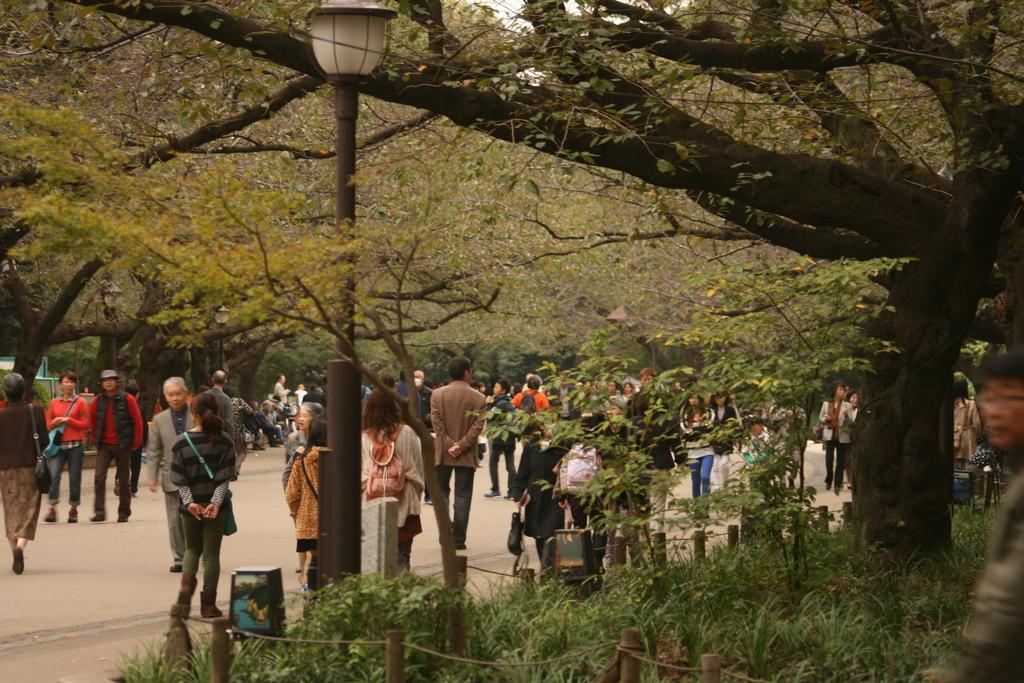What is located at the front of the image? There is a fence in the front of the image. What can be seen in the image besides the fence? There are plants, a pole, and persons in the background of the image. What are the persons in the background of the image doing? There are persons standing and walking in the background of the image. What type of vegetation is visible in the background of the image? There are trees in the background of the image. What is the amount of north visible in the image? The concept of "north" is not applicable to the image, as it refers to a direction and not a visible element. 